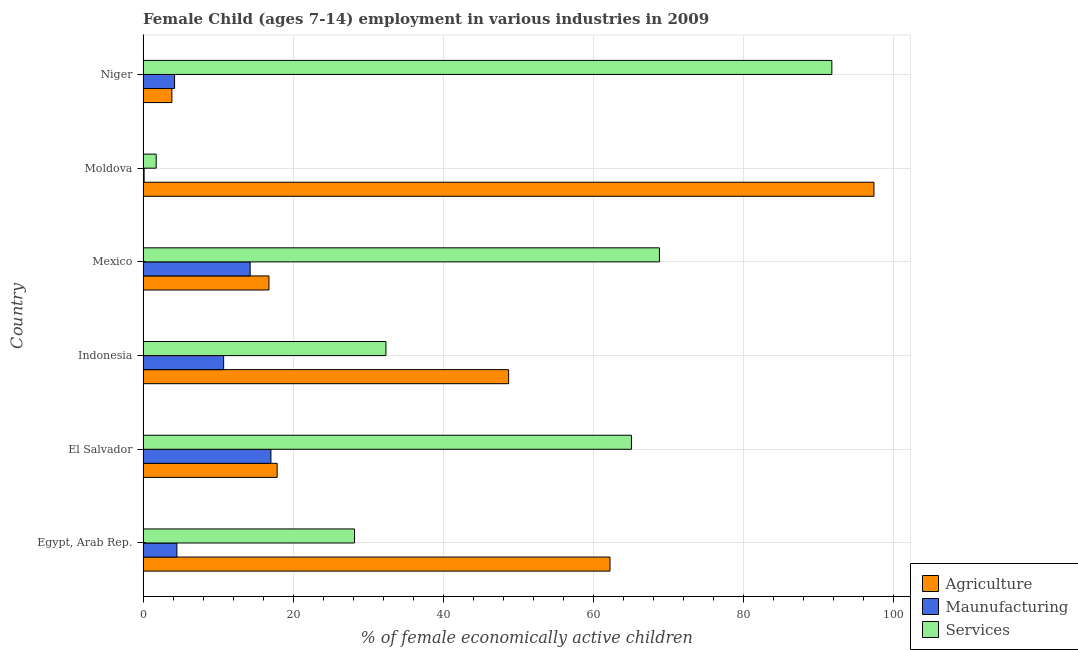How many groups of bars are there?
Make the answer very short. 6. How many bars are there on the 5th tick from the top?
Your answer should be compact. 3. What is the label of the 6th group of bars from the top?
Give a very brief answer. Egypt, Arab Rep. In how many cases, is the number of bars for a given country not equal to the number of legend labels?
Your response must be concise. 0. What is the percentage of economically active children in manufacturing in Moldova?
Your answer should be compact. 0.14. Across all countries, what is the maximum percentage of economically active children in services?
Provide a short and direct response. 91.8. Across all countries, what is the minimum percentage of economically active children in manufacturing?
Provide a succinct answer. 0.14. In which country was the percentage of economically active children in manufacturing maximum?
Ensure brevity in your answer.  El Salvador. In which country was the percentage of economically active children in services minimum?
Your response must be concise. Moldova. What is the total percentage of economically active children in manufacturing in the graph?
Make the answer very short. 50.9. What is the difference between the percentage of economically active children in agriculture in El Salvador and that in Indonesia?
Make the answer very short. -30.85. What is the difference between the percentage of economically active children in services in Niger and the percentage of economically active children in agriculture in El Salvador?
Your response must be concise. 73.93. What is the average percentage of economically active children in agriculture per country?
Keep it short and to the point. 41.14. What is the difference between the percentage of economically active children in services and percentage of economically active children in agriculture in Niger?
Your answer should be very brief. 87.96. What is the ratio of the percentage of economically active children in agriculture in Moldova to that in Niger?
Your answer should be compact. 25.37. Is the percentage of economically active children in services in Egypt, Arab Rep. less than that in Mexico?
Your response must be concise. Yes. What is the difference between the highest and the second highest percentage of economically active children in manufacturing?
Ensure brevity in your answer.  2.77. What is the difference between the highest and the lowest percentage of economically active children in services?
Provide a short and direct response. 90.05. Is the sum of the percentage of economically active children in agriculture in El Salvador and Mexico greater than the maximum percentage of economically active children in services across all countries?
Provide a succinct answer. No. What does the 3rd bar from the top in El Salvador represents?
Offer a very short reply. Agriculture. What does the 1st bar from the bottom in El Salvador represents?
Make the answer very short. Agriculture. How many bars are there?
Provide a short and direct response. 18. Does the graph contain any zero values?
Ensure brevity in your answer.  No. Does the graph contain grids?
Your answer should be compact. Yes. Where does the legend appear in the graph?
Provide a succinct answer. Bottom right. What is the title of the graph?
Your answer should be compact. Female Child (ages 7-14) employment in various industries in 2009. Does "Grants" appear as one of the legend labels in the graph?
Your response must be concise. No. What is the label or title of the X-axis?
Keep it short and to the point. % of female economically active children. What is the label or title of the Y-axis?
Make the answer very short. Country. What is the % of female economically active children of Agriculture in Egypt, Arab Rep.?
Provide a succinct answer. 62.23. What is the % of female economically active children of Maunufacturing in Egypt, Arab Rep.?
Your answer should be very brief. 4.51. What is the % of female economically active children of Services in Egypt, Arab Rep.?
Your answer should be compact. 28.18. What is the % of female economically active children of Agriculture in El Salvador?
Ensure brevity in your answer.  17.87. What is the % of female economically active children in Maunufacturing in El Salvador?
Offer a terse response. 17.04. What is the % of female economically active children of Services in El Salvador?
Your answer should be compact. 65.09. What is the % of female economically active children in Agriculture in Indonesia?
Make the answer very short. 48.72. What is the % of female economically active children of Maunufacturing in Indonesia?
Make the answer very short. 10.74. What is the % of female economically active children in Services in Indonesia?
Your answer should be compact. 32.37. What is the % of female economically active children of Agriculture in Mexico?
Offer a terse response. 16.78. What is the % of female economically active children of Maunufacturing in Mexico?
Ensure brevity in your answer.  14.27. What is the % of female economically active children in Services in Mexico?
Offer a very short reply. 68.82. What is the % of female economically active children in Agriculture in Moldova?
Keep it short and to the point. 97.41. What is the % of female economically active children of Maunufacturing in Moldova?
Your answer should be compact. 0.14. What is the % of female economically active children in Services in Moldova?
Ensure brevity in your answer.  1.75. What is the % of female economically active children of Agriculture in Niger?
Your response must be concise. 3.84. What is the % of female economically active children of Services in Niger?
Provide a succinct answer. 91.8. Across all countries, what is the maximum % of female economically active children in Agriculture?
Your answer should be compact. 97.41. Across all countries, what is the maximum % of female economically active children of Maunufacturing?
Ensure brevity in your answer.  17.04. Across all countries, what is the maximum % of female economically active children in Services?
Your response must be concise. 91.8. Across all countries, what is the minimum % of female economically active children of Agriculture?
Your answer should be compact. 3.84. Across all countries, what is the minimum % of female economically active children in Maunufacturing?
Keep it short and to the point. 0.14. What is the total % of female economically active children in Agriculture in the graph?
Provide a short and direct response. 246.85. What is the total % of female economically active children in Maunufacturing in the graph?
Give a very brief answer. 50.9. What is the total % of female economically active children in Services in the graph?
Give a very brief answer. 288.01. What is the difference between the % of female economically active children in Agriculture in Egypt, Arab Rep. and that in El Salvador?
Give a very brief answer. 44.36. What is the difference between the % of female economically active children of Maunufacturing in Egypt, Arab Rep. and that in El Salvador?
Offer a very short reply. -12.53. What is the difference between the % of female economically active children of Services in Egypt, Arab Rep. and that in El Salvador?
Your answer should be compact. -36.91. What is the difference between the % of female economically active children in Agriculture in Egypt, Arab Rep. and that in Indonesia?
Your answer should be very brief. 13.51. What is the difference between the % of female economically active children in Maunufacturing in Egypt, Arab Rep. and that in Indonesia?
Offer a terse response. -6.23. What is the difference between the % of female economically active children in Services in Egypt, Arab Rep. and that in Indonesia?
Your answer should be very brief. -4.19. What is the difference between the % of female economically active children of Agriculture in Egypt, Arab Rep. and that in Mexico?
Give a very brief answer. 45.45. What is the difference between the % of female economically active children of Maunufacturing in Egypt, Arab Rep. and that in Mexico?
Provide a short and direct response. -9.76. What is the difference between the % of female economically active children of Services in Egypt, Arab Rep. and that in Mexico?
Offer a very short reply. -40.64. What is the difference between the % of female economically active children of Agriculture in Egypt, Arab Rep. and that in Moldova?
Give a very brief answer. -35.18. What is the difference between the % of female economically active children of Maunufacturing in Egypt, Arab Rep. and that in Moldova?
Provide a short and direct response. 4.37. What is the difference between the % of female economically active children of Services in Egypt, Arab Rep. and that in Moldova?
Ensure brevity in your answer.  26.43. What is the difference between the % of female economically active children in Agriculture in Egypt, Arab Rep. and that in Niger?
Give a very brief answer. 58.39. What is the difference between the % of female economically active children of Maunufacturing in Egypt, Arab Rep. and that in Niger?
Provide a short and direct response. 0.31. What is the difference between the % of female economically active children in Services in Egypt, Arab Rep. and that in Niger?
Offer a very short reply. -63.62. What is the difference between the % of female economically active children in Agriculture in El Salvador and that in Indonesia?
Keep it short and to the point. -30.85. What is the difference between the % of female economically active children in Services in El Salvador and that in Indonesia?
Your response must be concise. 32.72. What is the difference between the % of female economically active children of Agriculture in El Salvador and that in Mexico?
Keep it short and to the point. 1.09. What is the difference between the % of female economically active children of Maunufacturing in El Salvador and that in Mexico?
Ensure brevity in your answer.  2.77. What is the difference between the % of female economically active children of Services in El Salvador and that in Mexico?
Give a very brief answer. -3.73. What is the difference between the % of female economically active children of Agriculture in El Salvador and that in Moldova?
Give a very brief answer. -79.54. What is the difference between the % of female economically active children of Services in El Salvador and that in Moldova?
Ensure brevity in your answer.  63.34. What is the difference between the % of female economically active children of Agriculture in El Salvador and that in Niger?
Give a very brief answer. 14.03. What is the difference between the % of female economically active children of Maunufacturing in El Salvador and that in Niger?
Your response must be concise. 12.84. What is the difference between the % of female economically active children in Services in El Salvador and that in Niger?
Ensure brevity in your answer.  -26.71. What is the difference between the % of female economically active children in Agriculture in Indonesia and that in Mexico?
Your response must be concise. 31.94. What is the difference between the % of female economically active children in Maunufacturing in Indonesia and that in Mexico?
Your response must be concise. -3.53. What is the difference between the % of female economically active children in Services in Indonesia and that in Mexico?
Provide a short and direct response. -36.45. What is the difference between the % of female economically active children of Agriculture in Indonesia and that in Moldova?
Make the answer very short. -48.69. What is the difference between the % of female economically active children in Services in Indonesia and that in Moldova?
Your response must be concise. 30.62. What is the difference between the % of female economically active children in Agriculture in Indonesia and that in Niger?
Offer a very short reply. 44.88. What is the difference between the % of female economically active children in Maunufacturing in Indonesia and that in Niger?
Your response must be concise. 6.54. What is the difference between the % of female economically active children in Services in Indonesia and that in Niger?
Offer a very short reply. -59.43. What is the difference between the % of female economically active children in Agriculture in Mexico and that in Moldova?
Give a very brief answer. -80.63. What is the difference between the % of female economically active children of Maunufacturing in Mexico and that in Moldova?
Your answer should be very brief. 14.13. What is the difference between the % of female economically active children in Services in Mexico and that in Moldova?
Provide a short and direct response. 67.07. What is the difference between the % of female economically active children of Agriculture in Mexico and that in Niger?
Offer a terse response. 12.94. What is the difference between the % of female economically active children in Maunufacturing in Mexico and that in Niger?
Give a very brief answer. 10.07. What is the difference between the % of female economically active children in Services in Mexico and that in Niger?
Keep it short and to the point. -22.98. What is the difference between the % of female economically active children in Agriculture in Moldova and that in Niger?
Give a very brief answer. 93.57. What is the difference between the % of female economically active children of Maunufacturing in Moldova and that in Niger?
Give a very brief answer. -4.06. What is the difference between the % of female economically active children of Services in Moldova and that in Niger?
Your response must be concise. -90.05. What is the difference between the % of female economically active children of Agriculture in Egypt, Arab Rep. and the % of female economically active children of Maunufacturing in El Salvador?
Offer a very short reply. 45.19. What is the difference between the % of female economically active children of Agriculture in Egypt, Arab Rep. and the % of female economically active children of Services in El Salvador?
Provide a succinct answer. -2.86. What is the difference between the % of female economically active children of Maunufacturing in Egypt, Arab Rep. and the % of female economically active children of Services in El Salvador?
Offer a very short reply. -60.58. What is the difference between the % of female economically active children in Agriculture in Egypt, Arab Rep. and the % of female economically active children in Maunufacturing in Indonesia?
Provide a succinct answer. 51.49. What is the difference between the % of female economically active children of Agriculture in Egypt, Arab Rep. and the % of female economically active children of Services in Indonesia?
Provide a succinct answer. 29.86. What is the difference between the % of female economically active children in Maunufacturing in Egypt, Arab Rep. and the % of female economically active children in Services in Indonesia?
Keep it short and to the point. -27.86. What is the difference between the % of female economically active children of Agriculture in Egypt, Arab Rep. and the % of female economically active children of Maunufacturing in Mexico?
Provide a short and direct response. 47.96. What is the difference between the % of female economically active children in Agriculture in Egypt, Arab Rep. and the % of female economically active children in Services in Mexico?
Offer a terse response. -6.59. What is the difference between the % of female economically active children in Maunufacturing in Egypt, Arab Rep. and the % of female economically active children in Services in Mexico?
Offer a very short reply. -64.31. What is the difference between the % of female economically active children in Agriculture in Egypt, Arab Rep. and the % of female economically active children in Maunufacturing in Moldova?
Keep it short and to the point. 62.09. What is the difference between the % of female economically active children in Agriculture in Egypt, Arab Rep. and the % of female economically active children in Services in Moldova?
Your answer should be very brief. 60.48. What is the difference between the % of female economically active children in Maunufacturing in Egypt, Arab Rep. and the % of female economically active children in Services in Moldova?
Provide a short and direct response. 2.76. What is the difference between the % of female economically active children of Agriculture in Egypt, Arab Rep. and the % of female economically active children of Maunufacturing in Niger?
Offer a very short reply. 58.03. What is the difference between the % of female economically active children of Agriculture in Egypt, Arab Rep. and the % of female economically active children of Services in Niger?
Offer a very short reply. -29.57. What is the difference between the % of female economically active children in Maunufacturing in Egypt, Arab Rep. and the % of female economically active children in Services in Niger?
Your answer should be very brief. -87.29. What is the difference between the % of female economically active children of Agriculture in El Salvador and the % of female economically active children of Maunufacturing in Indonesia?
Ensure brevity in your answer.  7.13. What is the difference between the % of female economically active children of Maunufacturing in El Salvador and the % of female economically active children of Services in Indonesia?
Keep it short and to the point. -15.33. What is the difference between the % of female economically active children in Agriculture in El Salvador and the % of female economically active children in Maunufacturing in Mexico?
Your answer should be compact. 3.6. What is the difference between the % of female economically active children in Agriculture in El Salvador and the % of female economically active children in Services in Mexico?
Your response must be concise. -50.95. What is the difference between the % of female economically active children in Maunufacturing in El Salvador and the % of female economically active children in Services in Mexico?
Keep it short and to the point. -51.78. What is the difference between the % of female economically active children of Agriculture in El Salvador and the % of female economically active children of Maunufacturing in Moldova?
Your answer should be compact. 17.73. What is the difference between the % of female economically active children of Agriculture in El Salvador and the % of female economically active children of Services in Moldova?
Provide a short and direct response. 16.12. What is the difference between the % of female economically active children in Maunufacturing in El Salvador and the % of female economically active children in Services in Moldova?
Your answer should be very brief. 15.29. What is the difference between the % of female economically active children of Agriculture in El Salvador and the % of female economically active children of Maunufacturing in Niger?
Offer a terse response. 13.67. What is the difference between the % of female economically active children of Agriculture in El Salvador and the % of female economically active children of Services in Niger?
Provide a succinct answer. -73.93. What is the difference between the % of female economically active children in Maunufacturing in El Salvador and the % of female economically active children in Services in Niger?
Your response must be concise. -74.76. What is the difference between the % of female economically active children in Agriculture in Indonesia and the % of female economically active children in Maunufacturing in Mexico?
Provide a succinct answer. 34.45. What is the difference between the % of female economically active children in Agriculture in Indonesia and the % of female economically active children in Services in Mexico?
Ensure brevity in your answer.  -20.1. What is the difference between the % of female economically active children in Maunufacturing in Indonesia and the % of female economically active children in Services in Mexico?
Offer a very short reply. -58.08. What is the difference between the % of female economically active children in Agriculture in Indonesia and the % of female economically active children in Maunufacturing in Moldova?
Offer a terse response. 48.58. What is the difference between the % of female economically active children of Agriculture in Indonesia and the % of female economically active children of Services in Moldova?
Make the answer very short. 46.97. What is the difference between the % of female economically active children of Maunufacturing in Indonesia and the % of female economically active children of Services in Moldova?
Give a very brief answer. 8.99. What is the difference between the % of female economically active children of Agriculture in Indonesia and the % of female economically active children of Maunufacturing in Niger?
Ensure brevity in your answer.  44.52. What is the difference between the % of female economically active children in Agriculture in Indonesia and the % of female economically active children in Services in Niger?
Provide a succinct answer. -43.08. What is the difference between the % of female economically active children in Maunufacturing in Indonesia and the % of female economically active children in Services in Niger?
Your response must be concise. -81.06. What is the difference between the % of female economically active children in Agriculture in Mexico and the % of female economically active children in Maunufacturing in Moldova?
Your answer should be compact. 16.64. What is the difference between the % of female economically active children of Agriculture in Mexico and the % of female economically active children of Services in Moldova?
Make the answer very short. 15.03. What is the difference between the % of female economically active children in Maunufacturing in Mexico and the % of female economically active children in Services in Moldova?
Give a very brief answer. 12.52. What is the difference between the % of female economically active children of Agriculture in Mexico and the % of female economically active children of Maunufacturing in Niger?
Keep it short and to the point. 12.58. What is the difference between the % of female economically active children of Agriculture in Mexico and the % of female economically active children of Services in Niger?
Offer a very short reply. -75.02. What is the difference between the % of female economically active children of Maunufacturing in Mexico and the % of female economically active children of Services in Niger?
Keep it short and to the point. -77.53. What is the difference between the % of female economically active children of Agriculture in Moldova and the % of female economically active children of Maunufacturing in Niger?
Provide a succinct answer. 93.21. What is the difference between the % of female economically active children of Agriculture in Moldova and the % of female economically active children of Services in Niger?
Your answer should be compact. 5.61. What is the difference between the % of female economically active children in Maunufacturing in Moldova and the % of female economically active children in Services in Niger?
Offer a terse response. -91.66. What is the average % of female economically active children of Agriculture per country?
Offer a terse response. 41.14. What is the average % of female economically active children in Maunufacturing per country?
Provide a succinct answer. 8.48. What is the average % of female economically active children in Services per country?
Keep it short and to the point. 48. What is the difference between the % of female economically active children in Agriculture and % of female economically active children in Maunufacturing in Egypt, Arab Rep.?
Keep it short and to the point. 57.72. What is the difference between the % of female economically active children in Agriculture and % of female economically active children in Services in Egypt, Arab Rep.?
Provide a short and direct response. 34.05. What is the difference between the % of female economically active children of Maunufacturing and % of female economically active children of Services in Egypt, Arab Rep.?
Your response must be concise. -23.67. What is the difference between the % of female economically active children of Agriculture and % of female economically active children of Maunufacturing in El Salvador?
Make the answer very short. 0.83. What is the difference between the % of female economically active children of Agriculture and % of female economically active children of Services in El Salvador?
Your answer should be compact. -47.22. What is the difference between the % of female economically active children of Maunufacturing and % of female economically active children of Services in El Salvador?
Provide a succinct answer. -48.05. What is the difference between the % of female economically active children of Agriculture and % of female economically active children of Maunufacturing in Indonesia?
Make the answer very short. 37.98. What is the difference between the % of female economically active children of Agriculture and % of female economically active children of Services in Indonesia?
Offer a terse response. 16.35. What is the difference between the % of female economically active children of Maunufacturing and % of female economically active children of Services in Indonesia?
Ensure brevity in your answer.  -21.63. What is the difference between the % of female economically active children in Agriculture and % of female economically active children in Maunufacturing in Mexico?
Your answer should be very brief. 2.51. What is the difference between the % of female economically active children of Agriculture and % of female economically active children of Services in Mexico?
Make the answer very short. -52.04. What is the difference between the % of female economically active children in Maunufacturing and % of female economically active children in Services in Mexico?
Offer a terse response. -54.55. What is the difference between the % of female economically active children of Agriculture and % of female economically active children of Maunufacturing in Moldova?
Your answer should be compact. 97.27. What is the difference between the % of female economically active children in Agriculture and % of female economically active children in Services in Moldova?
Offer a very short reply. 95.66. What is the difference between the % of female economically active children in Maunufacturing and % of female economically active children in Services in Moldova?
Ensure brevity in your answer.  -1.61. What is the difference between the % of female economically active children of Agriculture and % of female economically active children of Maunufacturing in Niger?
Your answer should be very brief. -0.36. What is the difference between the % of female economically active children in Agriculture and % of female economically active children in Services in Niger?
Make the answer very short. -87.96. What is the difference between the % of female economically active children of Maunufacturing and % of female economically active children of Services in Niger?
Offer a terse response. -87.6. What is the ratio of the % of female economically active children in Agriculture in Egypt, Arab Rep. to that in El Salvador?
Offer a very short reply. 3.48. What is the ratio of the % of female economically active children in Maunufacturing in Egypt, Arab Rep. to that in El Salvador?
Offer a very short reply. 0.26. What is the ratio of the % of female economically active children in Services in Egypt, Arab Rep. to that in El Salvador?
Ensure brevity in your answer.  0.43. What is the ratio of the % of female economically active children of Agriculture in Egypt, Arab Rep. to that in Indonesia?
Give a very brief answer. 1.28. What is the ratio of the % of female economically active children in Maunufacturing in Egypt, Arab Rep. to that in Indonesia?
Provide a succinct answer. 0.42. What is the ratio of the % of female economically active children of Services in Egypt, Arab Rep. to that in Indonesia?
Your answer should be very brief. 0.87. What is the ratio of the % of female economically active children in Agriculture in Egypt, Arab Rep. to that in Mexico?
Keep it short and to the point. 3.71. What is the ratio of the % of female economically active children in Maunufacturing in Egypt, Arab Rep. to that in Mexico?
Your answer should be very brief. 0.32. What is the ratio of the % of female economically active children of Services in Egypt, Arab Rep. to that in Mexico?
Give a very brief answer. 0.41. What is the ratio of the % of female economically active children of Agriculture in Egypt, Arab Rep. to that in Moldova?
Your answer should be very brief. 0.64. What is the ratio of the % of female economically active children of Maunufacturing in Egypt, Arab Rep. to that in Moldova?
Your response must be concise. 32.21. What is the ratio of the % of female economically active children of Services in Egypt, Arab Rep. to that in Moldova?
Provide a short and direct response. 16.1. What is the ratio of the % of female economically active children of Agriculture in Egypt, Arab Rep. to that in Niger?
Provide a short and direct response. 16.21. What is the ratio of the % of female economically active children of Maunufacturing in Egypt, Arab Rep. to that in Niger?
Ensure brevity in your answer.  1.07. What is the ratio of the % of female economically active children in Services in Egypt, Arab Rep. to that in Niger?
Give a very brief answer. 0.31. What is the ratio of the % of female economically active children of Agriculture in El Salvador to that in Indonesia?
Your answer should be compact. 0.37. What is the ratio of the % of female economically active children in Maunufacturing in El Salvador to that in Indonesia?
Give a very brief answer. 1.59. What is the ratio of the % of female economically active children of Services in El Salvador to that in Indonesia?
Provide a short and direct response. 2.01. What is the ratio of the % of female economically active children of Agriculture in El Salvador to that in Mexico?
Give a very brief answer. 1.06. What is the ratio of the % of female economically active children in Maunufacturing in El Salvador to that in Mexico?
Give a very brief answer. 1.19. What is the ratio of the % of female economically active children of Services in El Salvador to that in Mexico?
Your response must be concise. 0.95. What is the ratio of the % of female economically active children of Agriculture in El Salvador to that in Moldova?
Keep it short and to the point. 0.18. What is the ratio of the % of female economically active children of Maunufacturing in El Salvador to that in Moldova?
Offer a terse response. 121.71. What is the ratio of the % of female economically active children in Services in El Salvador to that in Moldova?
Make the answer very short. 37.19. What is the ratio of the % of female economically active children of Agriculture in El Salvador to that in Niger?
Your response must be concise. 4.65. What is the ratio of the % of female economically active children of Maunufacturing in El Salvador to that in Niger?
Your answer should be very brief. 4.06. What is the ratio of the % of female economically active children of Services in El Salvador to that in Niger?
Keep it short and to the point. 0.71. What is the ratio of the % of female economically active children of Agriculture in Indonesia to that in Mexico?
Your response must be concise. 2.9. What is the ratio of the % of female economically active children of Maunufacturing in Indonesia to that in Mexico?
Your answer should be compact. 0.75. What is the ratio of the % of female economically active children in Services in Indonesia to that in Mexico?
Your response must be concise. 0.47. What is the ratio of the % of female economically active children in Agriculture in Indonesia to that in Moldova?
Make the answer very short. 0.5. What is the ratio of the % of female economically active children in Maunufacturing in Indonesia to that in Moldova?
Offer a very short reply. 76.71. What is the ratio of the % of female economically active children in Services in Indonesia to that in Moldova?
Your answer should be very brief. 18.5. What is the ratio of the % of female economically active children of Agriculture in Indonesia to that in Niger?
Ensure brevity in your answer.  12.69. What is the ratio of the % of female economically active children of Maunufacturing in Indonesia to that in Niger?
Ensure brevity in your answer.  2.56. What is the ratio of the % of female economically active children of Services in Indonesia to that in Niger?
Offer a very short reply. 0.35. What is the ratio of the % of female economically active children of Agriculture in Mexico to that in Moldova?
Keep it short and to the point. 0.17. What is the ratio of the % of female economically active children of Maunufacturing in Mexico to that in Moldova?
Make the answer very short. 101.93. What is the ratio of the % of female economically active children of Services in Mexico to that in Moldova?
Ensure brevity in your answer.  39.33. What is the ratio of the % of female economically active children of Agriculture in Mexico to that in Niger?
Make the answer very short. 4.37. What is the ratio of the % of female economically active children of Maunufacturing in Mexico to that in Niger?
Your answer should be compact. 3.4. What is the ratio of the % of female economically active children in Services in Mexico to that in Niger?
Provide a short and direct response. 0.75. What is the ratio of the % of female economically active children in Agriculture in Moldova to that in Niger?
Your answer should be compact. 25.37. What is the ratio of the % of female economically active children in Services in Moldova to that in Niger?
Keep it short and to the point. 0.02. What is the difference between the highest and the second highest % of female economically active children in Agriculture?
Offer a terse response. 35.18. What is the difference between the highest and the second highest % of female economically active children of Maunufacturing?
Offer a very short reply. 2.77. What is the difference between the highest and the second highest % of female economically active children in Services?
Your response must be concise. 22.98. What is the difference between the highest and the lowest % of female economically active children of Agriculture?
Offer a very short reply. 93.57. What is the difference between the highest and the lowest % of female economically active children in Maunufacturing?
Provide a succinct answer. 16.9. What is the difference between the highest and the lowest % of female economically active children in Services?
Your response must be concise. 90.05. 